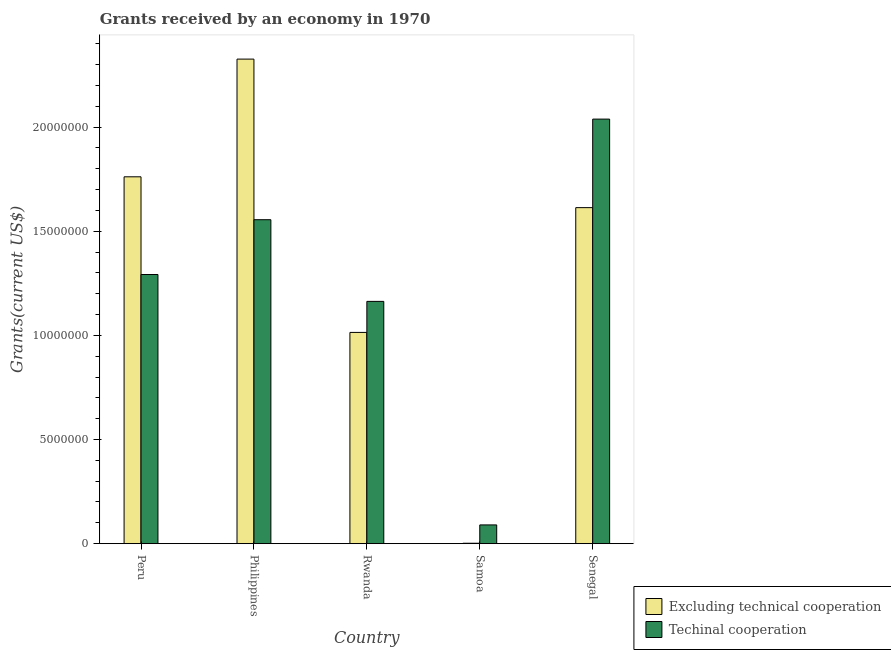How many different coloured bars are there?
Offer a very short reply. 2. How many groups of bars are there?
Your response must be concise. 5. Are the number of bars per tick equal to the number of legend labels?
Give a very brief answer. Yes. How many bars are there on the 1st tick from the left?
Your answer should be very brief. 2. How many bars are there on the 5th tick from the right?
Make the answer very short. 2. What is the label of the 4th group of bars from the left?
Ensure brevity in your answer.  Samoa. What is the amount of grants received(including technical cooperation) in Samoa?
Give a very brief answer. 9.00e+05. Across all countries, what is the maximum amount of grants received(excluding technical cooperation)?
Your answer should be compact. 2.33e+07. Across all countries, what is the minimum amount of grants received(including technical cooperation)?
Ensure brevity in your answer.  9.00e+05. In which country was the amount of grants received(including technical cooperation) maximum?
Your response must be concise. Senegal. In which country was the amount of grants received(including technical cooperation) minimum?
Offer a very short reply. Samoa. What is the total amount of grants received(excluding technical cooperation) in the graph?
Provide a short and direct response. 6.72e+07. What is the difference between the amount of grants received(excluding technical cooperation) in Rwanda and that in Senegal?
Keep it short and to the point. -5.99e+06. What is the difference between the amount of grants received(including technical cooperation) in Senegal and the amount of grants received(excluding technical cooperation) in Peru?
Offer a very short reply. 2.77e+06. What is the average amount of grants received(including technical cooperation) per country?
Your answer should be compact. 1.23e+07. What is the difference between the amount of grants received(including technical cooperation) and amount of grants received(excluding technical cooperation) in Senegal?
Your answer should be very brief. 4.25e+06. What is the ratio of the amount of grants received(excluding technical cooperation) in Samoa to that in Senegal?
Your answer should be very brief. 0. Is the difference between the amount of grants received(including technical cooperation) in Rwanda and Senegal greater than the difference between the amount of grants received(excluding technical cooperation) in Rwanda and Senegal?
Your response must be concise. No. What is the difference between the highest and the second highest amount of grants received(including technical cooperation)?
Provide a short and direct response. 4.83e+06. What is the difference between the highest and the lowest amount of grants received(excluding technical cooperation)?
Ensure brevity in your answer.  2.32e+07. What does the 1st bar from the left in Senegal represents?
Keep it short and to the point. Excluding technical cooperation. What does the 2nd bar from the right in Philippines represents?
Make the answer very short. Excluding technical cooperation. Are all the bars in the graph horizontal?
Ensure brevity in your answer.  No. How many countries are there in the graph?
Your answer should be very brief. 5. What is the difference between two consecutive major ticks on the Y-axis?
Make the answer very short. 5.00e+06. Are the values on the major ticks of Y-axis written in scientific E-notation?
Your answer should be very brief. No. Does the graph contain any zero values?
Your answer should be very brief. No. Does the graph contain grids?
Your answer should be very brief. No. How are the legend labels stacked?
Your answer should be compact. Vertical. What is the title of the graph?
Offer a very short reply. Grants received by an economy in 1970. Does "Under-five" appear as one of the legend labels in the graph?
Your answer should be compact. No. What is the label or title of the Y-axis?
Your answer should be compact. Grants(current US$). What is the Grants(current US$) in Excluding technical cooperation in Peru?
Keep it short and to the point. 1.76e+07. What is the Grants(current US$) in Techinal cooperation in Peru?
Your answer should be very brief. 1.29e+07. What is the Grants(current US$) in Excluding technical cooperation in Philippines?
Ensure brevity in your answer.  2.33e+07. What is the Grants(current US$) of Techinal cooperation in Philippines?
Make the answer very short. 1.56e+07. What is the Grants(current US$) in Excluding technical cooperation in Rwanda?
Offer a very short reply. 1.01e+07. What is the Grants(current US$) of Techinal cooperation in Rwanda?
Offer a very short reply. 1.16e+07. What is the Grants(current US$) in Excluding technical cooperation in Samoa?
Keep it short and to the point. 2.00e+04. What is the Grants(current US$) of Excluding technical cooperation in Senegal?
Provide a short and direct response. 1.61e+07. What is the Grants(current US$) of Techinal cooperation in Senegal?
Give a very brief answer. 2.04e+07. Across all countries, what is the maximum Grants(current US$) in Excluding technical cooperation?
Offer a terse response. 2.33e+07. Across all countries, what is the maximum Grants(current US$) in Techinal cooperation?
Your answer should be compact. 2.04e+07. Across all countries, what is the minimum Grants(current US$) in Techinal cooperation?
Keep it short and to the point. 9.00e+05. What is the total Grants(current US$) of Excluding technical cooperation in the graph?
Your answer should be very brief. 6.72e+07. What is the total Grants(current US$) of Techinal cooperation in the graph?
Your answer should be compact. 6.14e+07. What is the difference between the Grants(current US$) in Excluding technical cooperation in Peru and that in Philippines?
Your answer should be very brief. -5.65e+06. What is the difference between the Grants(current US$) of Techinal cooperation in Peru and that in Philippines?
Make the answer very short. -2.63e+06. What is the difference between the Grants(current US$) of Excluding technical cooperation in Peru and that in Rwanda?
Ensure brevity in your answer.  7.47e+06. What is the difference between the Grants(current US$) in Techinal cooperation in Peru and that in Rwanda?
Make the answer very short. 1.29e+06. What is the difference between the Grants(current US$) of Excluding technical cooperation in Peru and that in Samoa?
Offer a very short reply. 1.76e+07. What is the difference between the Grants(current US$) in Techinal cooperation in Peru and that in Samoa?
Your answer should be very brief. 1.20e+07. What is the difference between the Grants(current US$) in Excluding technical cooperation in Peru and that in Senegal?
Your response must be concise. 1.48e+06. What is the difference between the Grants(current US$) of Techinal cooperation in Peru and that in Senegal?
Offer a very short reply. -7.46e+06. What is the difference between the Grants(current US$) in Excluding technical cooperation in Philippines and that in Rwanda?
Your answer should be compact. 1.31e+07. What is the difference between the Grants(current US$) in Techinal cooperation in Philippines and that in Rwanda?
Provide a succinct answer. 3.92e+06. What is the difference between the Grants(current US$) of Excluding technical cooperation in Philippines and that in Samoa?
Provide a succinct answer. 2.32e+07. What is the difference between the Grants(current US$) of Techinal cooperation in Philippines and that in Samoa?
Provide a succinct answer. 1.46e+07. What is the difference between the Grants(current US$) in Excluding technical cooperation in Philippines and that in Senegal?
Ensure brevity in your answer.  7.13e+06. What is the difference between the Grants(current US$) in Techinal cooperation in Philippines and that in Senegal?
Offer a terse response. -4.83e+06. What is the difference between the Grants(current US$) of Excluding technical cooperation in Rwanda and that in Samoa?
Your answer should be compact. 1.01e+07. What is the difference between the Grants(current US$) in Techinal cooperation in Rwanda and that in Samoa?
Provide a short and direct response. 1.07e+07. What is the difference between the Grants(current US$) in Excluding technical cooperation in Rwanda and that in Senegal?
Keep it short and to the point. -5.99e+06. What is the difference between the Grants(current US$) of Techinal cooperation in Rwanda and that in Senegal?
Your response must be concise. -8.75e+06. What is the difference between the Grants(current US$) in Excluding technical cooperation in Samoa and that in Senegal?
Offer a very short reply. -1.61e+07. What is the difference between the Grants(current US$) in Techinal cooperation in Samoa and that in Senegal?
Provide a short and direct response. -1.95e+07. What is the difference between the Grants(current US$) in Excluding technical cooperation in Peru and the Grants(current US$) in Techinal cooperation in Philippines?
Keep it short and to the point. 2.06e+06. What is the difference between the Grants(current US$) in Excluding technical cooperation in Peru and the Grants(current US$) in Techinal cooperation in Rwanda?
Provide a succinct answer. 5.98e+06. What is the difference between the Grants(current US$) in Excluding technical cooperation in Peru and the Grants(current US$) in Techinal cooperation in Samoa?
Ensure brevity in your answer.  1.67e+07. What is the difference between the Grants(current US$) in Excluding technical cooperation in Peru and the Grants(current US$) in Techinal cooperation in Senegal?
Provide a short and direct response. -2.77e+06. What is the difference between the Grants(current US$) of Excluding technical cooperation in Philippines and the Grants(current US$) of Techinal cooperation in Rwanda?
Give a very brief answer. 1.16e+07. What is the difference between the Grants(current US$) in Excluding technical cooperation in Philippines and the Grants(current US$) in Techinal cooperation in Samoa?
Your response must be concise. 2.24e+07. What is the difference between the Grants(current US$) of Excluding technical cooperation in Philippines and the Grants(current US$) of Techinal cooperation in Senegal?
Your answer should be compact. 2.88e+06. What is the difference between the Grants(current US$) of Excluding technical cooperation in Rwanda and the Grants(current US$) of Techinal cooperation in Samoa?
Your answer should be very brief. 9.24e+06. What is the difference between the Grants(current US$) in Excluding technical cooperation in Rwanda and the Grants(current US$) in Techinal cooperation in Senegal?
Your response must be concise. -1.02e+07. What is the difference between the Grants(current US$) of Excluding technical cooperation in Samoa and the Grants(current US$) of Techinal cooperation in Senegal?
Your answer should be very brief. -2.04e+07. What is the average Grants(current US$) of Excluding technical cooperation per country?
Your answer should be very brief. 1.34e+07. What is the average Grants(current US$) in Techinal cooperation per country?
Make the answer very short. 1.23e+07. What is the difference between the Grants(current US$) in Excluding technical cooperation and Grants(current US$) in Techinal cooperation in Peru?
Your response must be concise. 4.69e+06. What is the difference between the Grants(current US$) of Excluding technical cooperation and Grants(current US$) of Techinal cooperation in Philippines?
Give a very brief answer. 7.71e+06. What is the difference between the Grants(current US$) in Excluding technical cooperation and Grants(current US$) in Techinal cooperation in Rwanda?
Provide a succinct answer. -1.49e+06. What is the difference between the Grants(current US$) in Excluding technical cooperation and Grants(current US$) in Techinal cooperation in Samoa?
Your response must be concise. -8.80e+05. What is the difference between the Grants(current US$) of Excluding technical cooperation and Grants(current US$) of Techinal cooperation in Senegal?
Provide a succinct answer. -4.25e+06. What is the ratio of the Grants(current US$) in Excluding technical cooperation in Peru to that in Philippines?
Give a very brief answer. 0.76. What is the ratio of the Grants(current US$) in Techinal cooperation in Peru to that in Philippines?
Offer a terse response. 0.83. What is the ratio of the Grants(current US$) in Excluding technical cooperation in Peru to that in Rwanda?
Make the answer very short. 1.74. What is the ratio of the Grants(current US$) in Techinal cooperation in Peru to that in Rwanda?
Make the answer very short. 1.11. What is the ratio of the Grants(current US$) in Excluding technical cooperation in Peru to that in Samoa?
Your answer should be very brief. 880.5. What is the ratio of the Grants(current US$) in Techinal cooperation in Peru to that in Samoa?
Your answer should be compact. 14.36. What is the ratio of the Grants(current US$) of Excluding technical cooperation in Peru to that in Senegal?
Give a very brief answer. 1.09. What is the ratio of the Grants(current US$) in Techinal cooperation in Peru to that in Senegal?
Offer a very short reply. 0.63. What is the ratio of the Grants(current US$) of Excluding technical cooperation in Philippines to that in Rwanda?
Offer a terse response. 2.29. What is the ratio of the Grants(current US$) of Techinal cooperation in Philippines to that in Rwanda?
Provide a short and direct response. 1.34. What is the ratio of the Grants(current US$) of Excluding technical cooperation in Philippines to that in Samoa?
Provide a succinct answer. 1163. What is the ratio of the Grants(current US$) in Techinal cooperation in Philippines to that in Samoa?
Your response must be concise. 17.28. What is the ratio of the Grants(current US$) in Excluding technical cooperation in Philippines to that in Senegal?
Offer a terse response. 1.44. What is the ratio of the Grants(current US$) of Techinal cooperation in Philippines to that in Senegal?
Your answer should be very brief. 0.76. What is the ratio of the Grants(current US$) of Excluding technical cooperation in Rwanda to that in Samoa?
Provide a short and direct response. 507. What is the ratio of the Grants(current US$) in Techinal cooperation in Rwanda to that in Samoa?
Give a very brief answer. 12.92. What is the ratio of the Grants(current US$) of Excluding technical cooperation in Rwanda to that in Senegal?
Provide a short and direct response. 0.63. What is the ratio of the Grants(current US$) in Techinal cooperation in Rwanda to that in Senegal?
Offer a very short reply. 0.57. What is the ratio of the Grants(current US$) of Excluding technical cooperation in Samoa to that in Senegal?
Offer a very short reply. 0. What is the ratio of the Grants(current US$) in Techinal cooperation in Samoa to that in Senegal?
Make the answer very short. 0.04. What is the difference between the highest and the second highest Grants(current US$) in Excluding technical cooperation?
Your answer should be very brief. 5.65e+06. What is the difference between the highest and the second highest Grants(current US$) in Techinal cooperation?
Provide a short and direct response. 4.83e+06. What is the difference between the highest and the lowest Grants(current US$) in Excluding technical cooperation?
Your answer should be very brief. 2.32e+07. What is the difference between the highest and the lowest Grants(current US$) in Techinal cooperation?
Ensure brevity in your answer.  1.95e+07. 